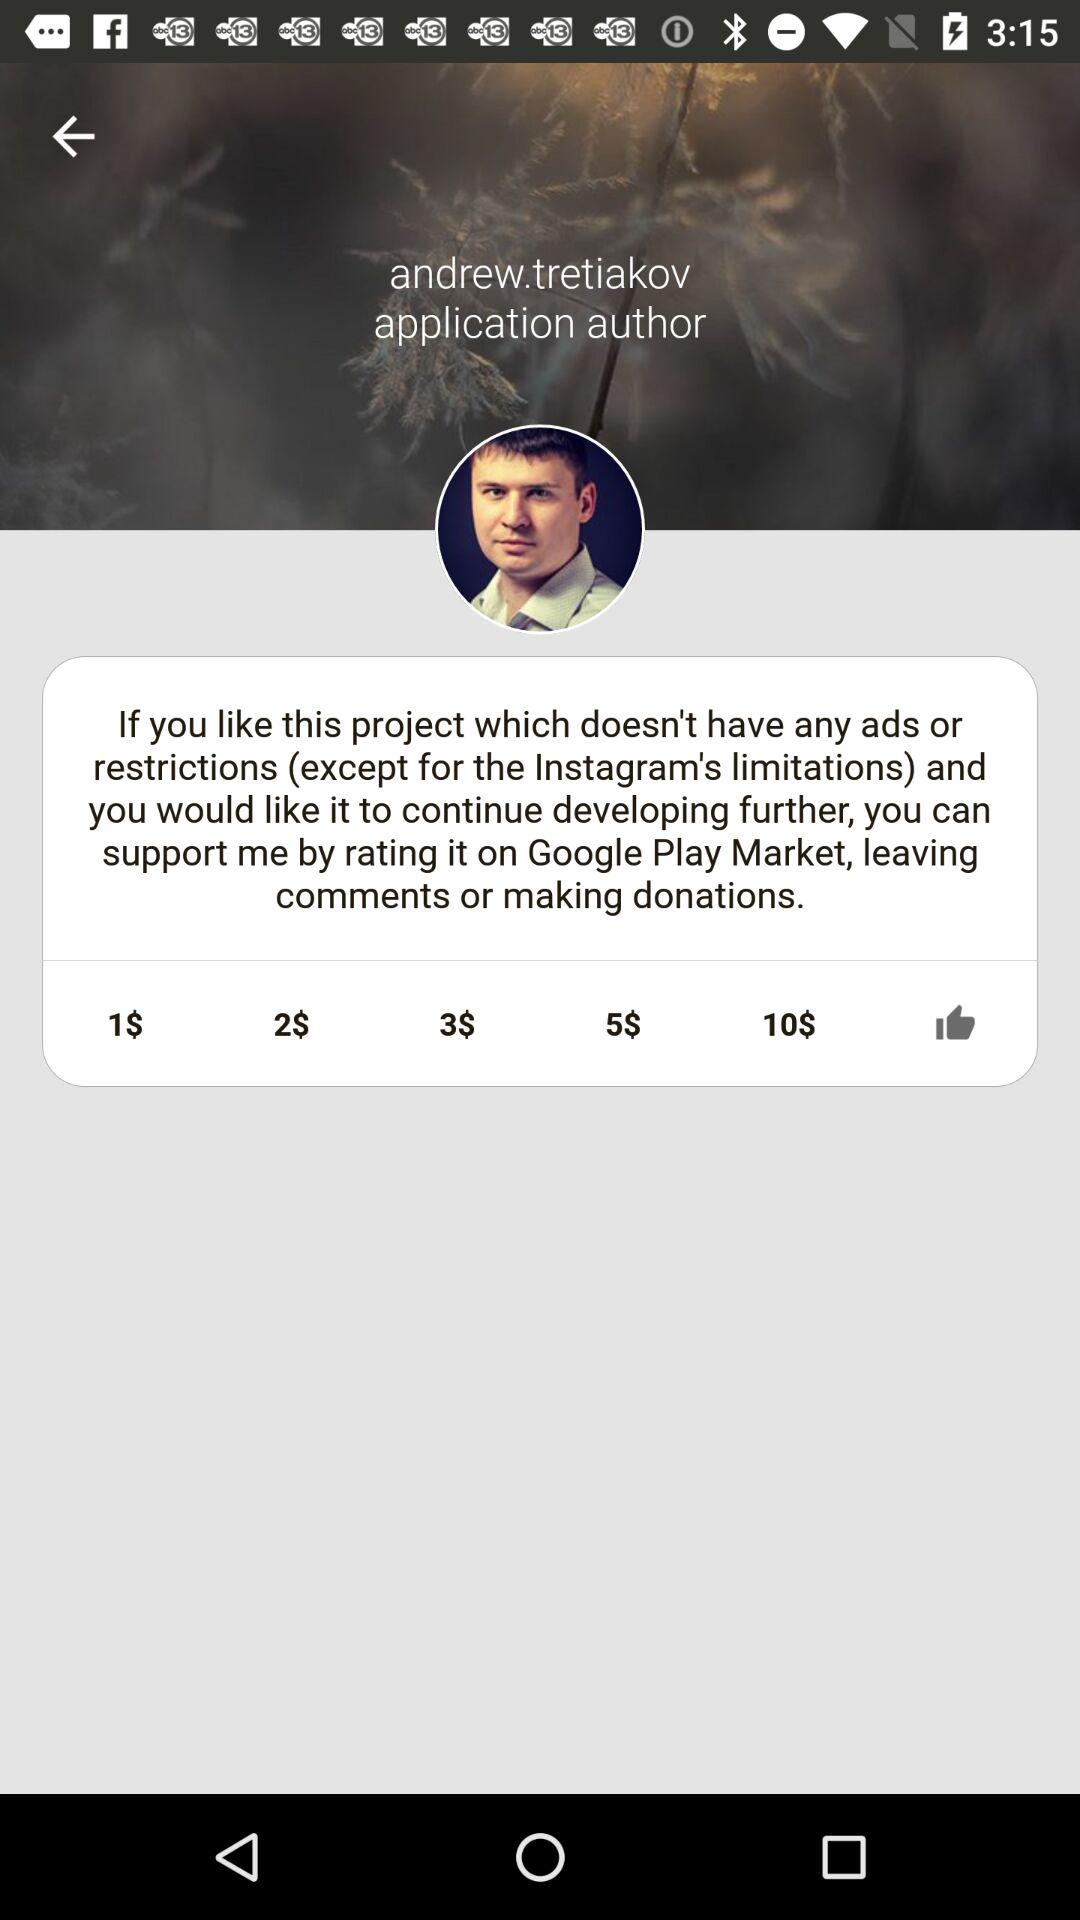How much can we donate? You can donate 1$, 2$, 3$, 5$, and 10$. 